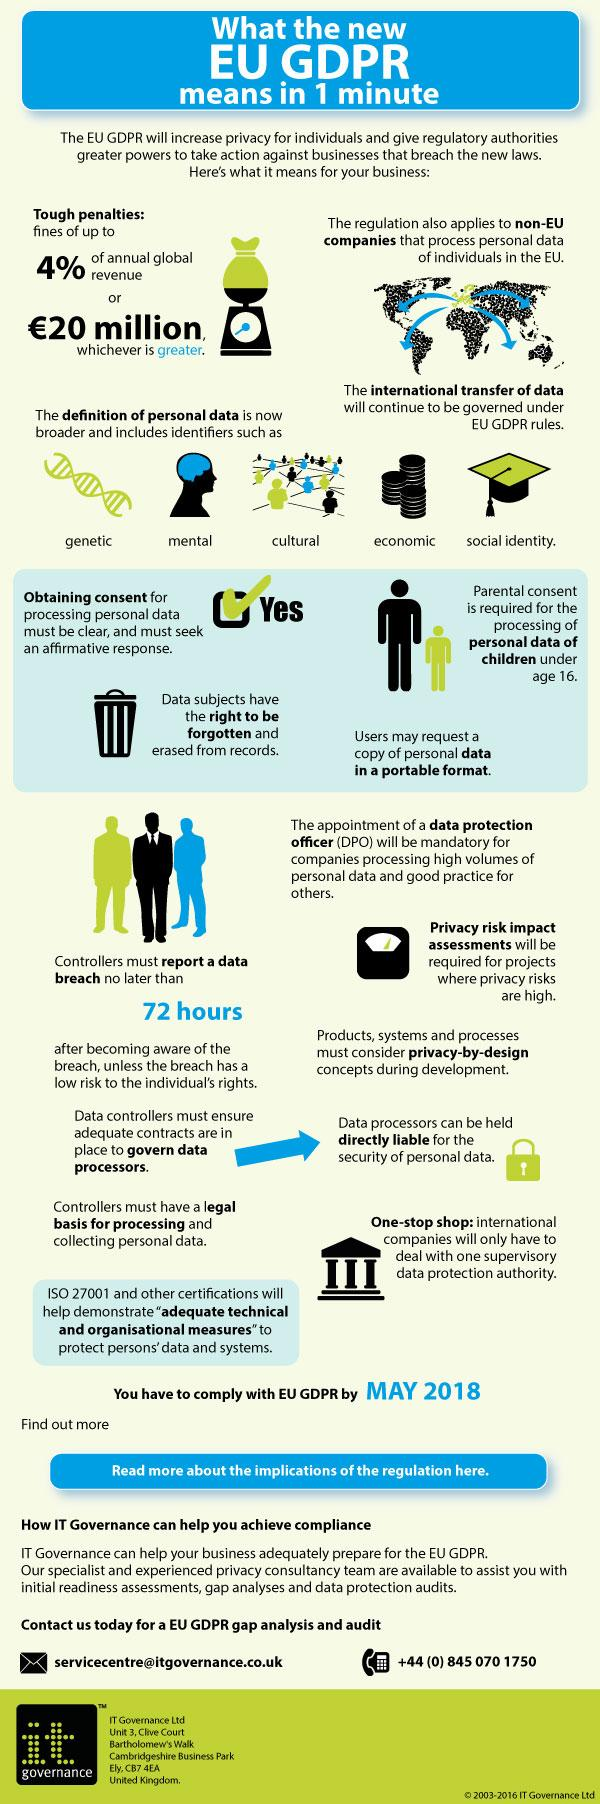Identify some key points in this picture. Parental consent is mandatory for dealing with the privacy data of children below 16 years old. The second type of personal data as given in the infographic is mental. It is advisable for a company to appoint a data protection officer when handling a large volume of personal data to ensure the proper protection and management of such data. The fourth type of personal data, as given in the infographic, is economic. 